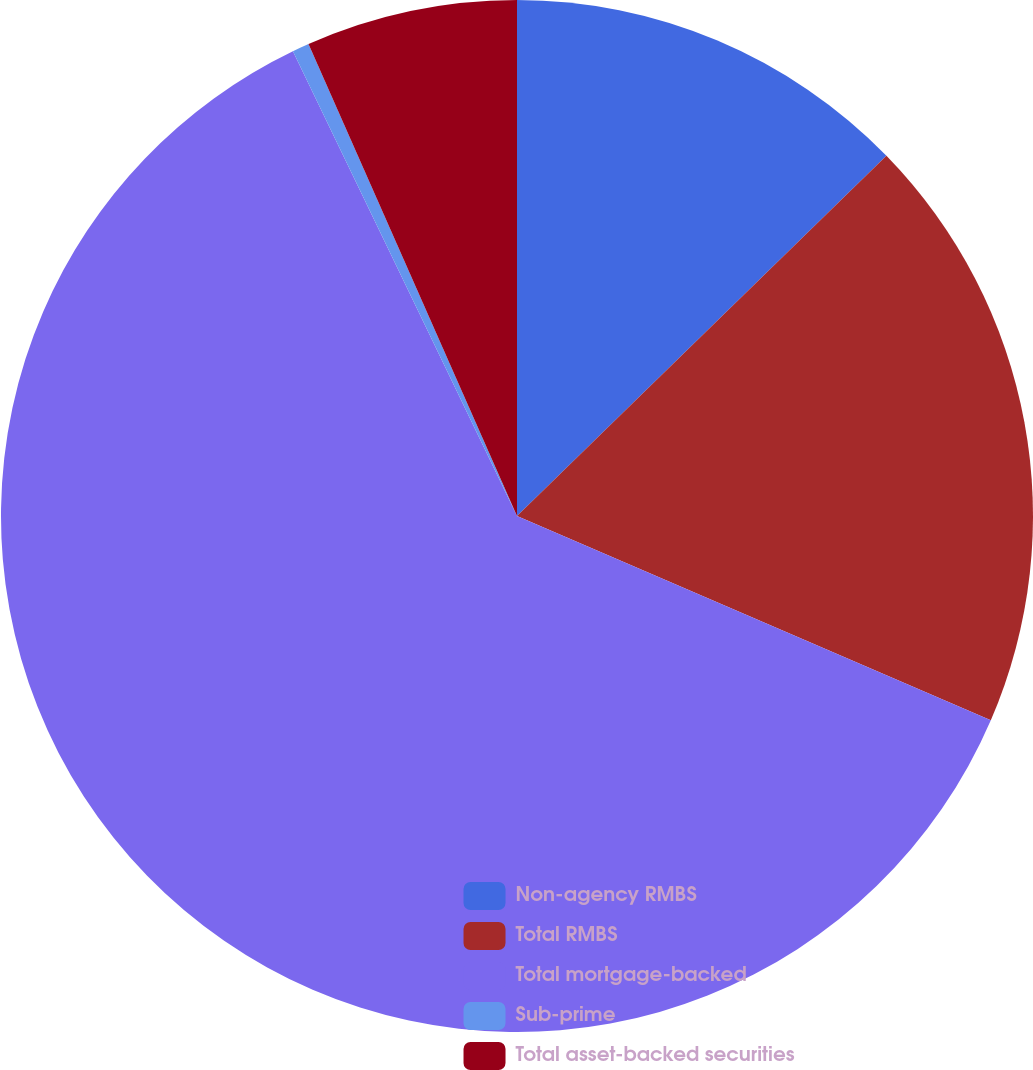<chart> <loc_0><loc_0><loc_500><loc_500><pie_chart><fcel>Non-agency RMBS<fcel>Total RMBS<fcel>Total mortgage-backed<fcel>Sub-prime<fcel>Total asset-backed securities<nl><fcel>12.7%<fcel>18.78%<fcel>61.37%<fcel>0.53%<fcel>6.62%<nl></chart> 